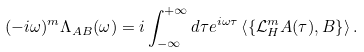<formula> <loc_0><loc_0><loc_500><loc_500>( - i \omega ) ^ { m } \Lambda _ { A B } ( \omega ) = i \int _ { - \infty } ^ { + \infty } d \tau e ^ { i \omega \tau } \left \langle \left \{ { \mathcal { L } _ { H } ^ { m } A ( \tau ) , B } \right \} \right \rangle .</formula> 